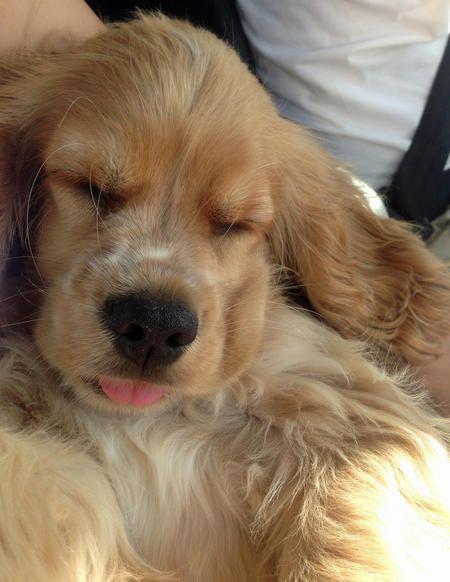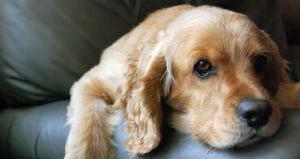The first image is the image on the left, the second image is the image on the right. Examine the images to the left and right. Is the description "One image includes at least one spaniel in a sleeping pose with shut eyes, and the other includes at least one 'ginger' spaniel with open eyes." accurate? Answer yes or no. Yes. 